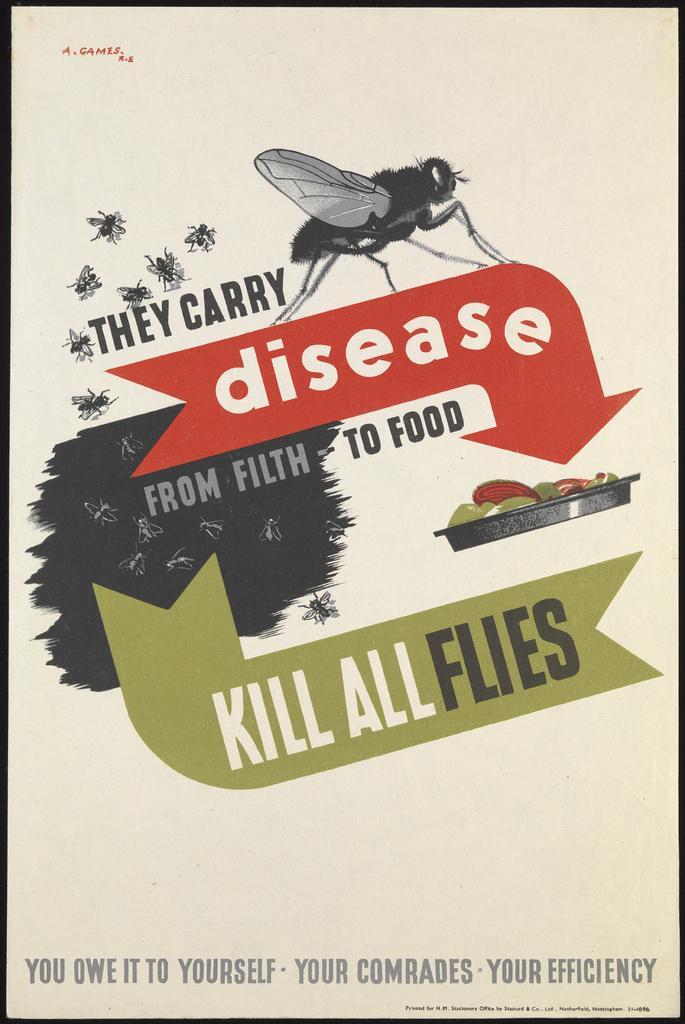Describe this image in one or two sentences. In this picture I can see a poster, on which there is something is written and I see the depiction of flies and food. 